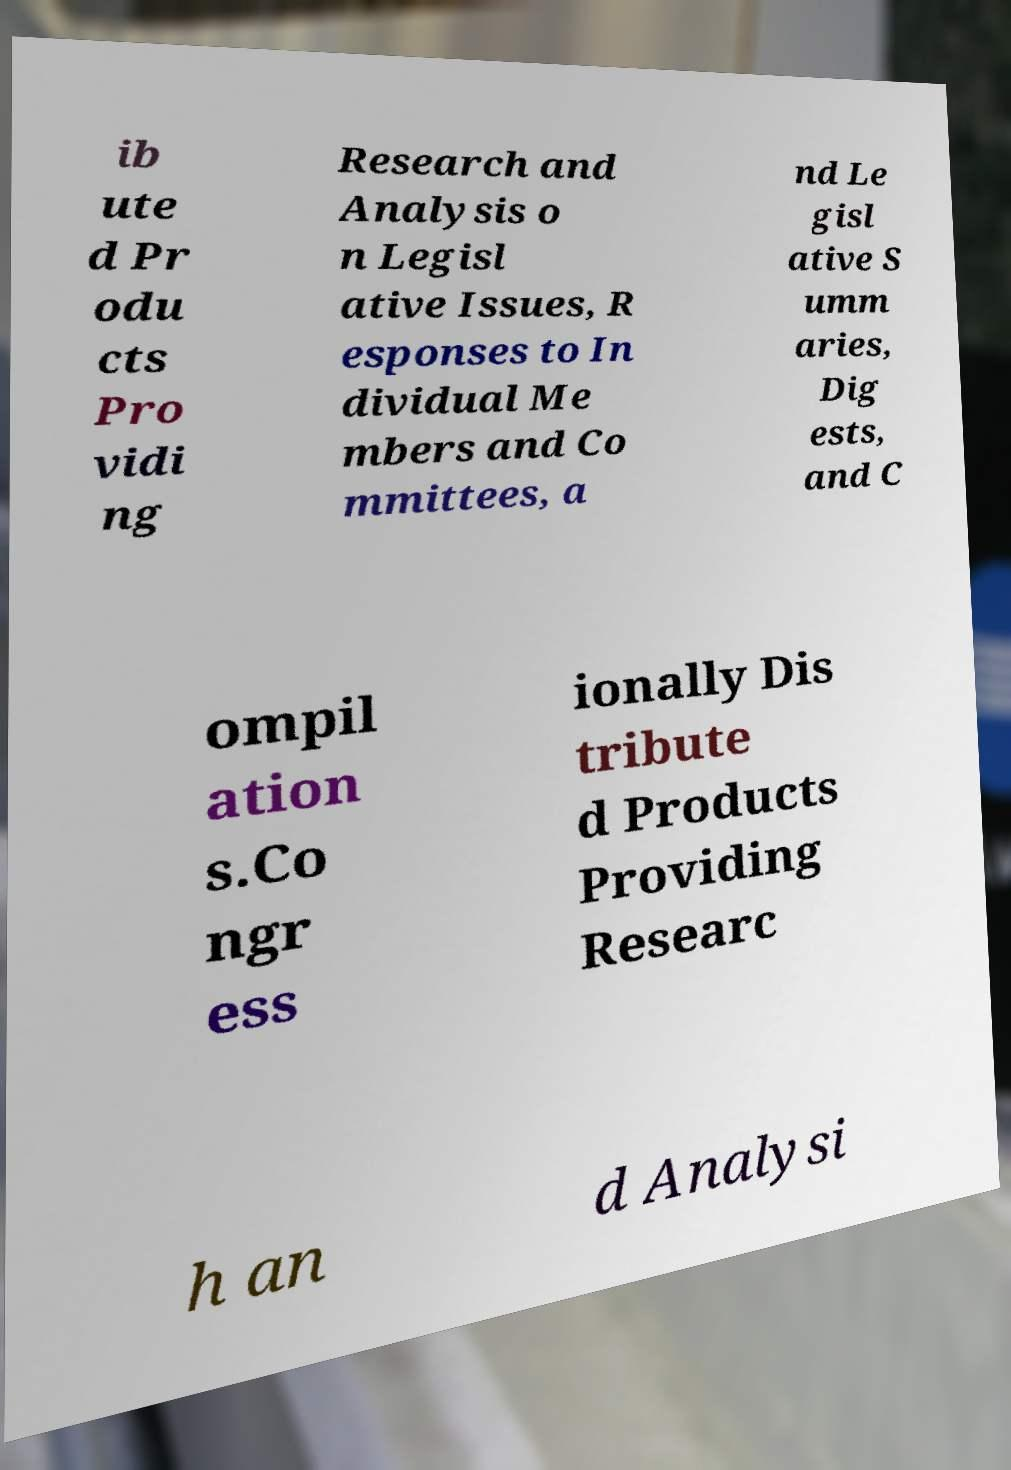Please identify and transcribe the text found in this image. ib ute d Pr odu cts Pro vidi ng Research and Analysis o n Legisl ative Issues, R esponses to In dividual Me mbers and Co mmittees, a nd Le gisl ative S umm aries, Dig ests, and C ompil ation s.Co ngr ess ionally Dis tribute d Products Providing Researc h an d Analysi 